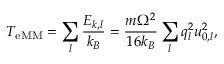Convert formula to latex. <formula><loc_0><loc_0><loc_500><loc_500>T _ { e M M } = \sum _ { l } \frac { E _ { k , l } } { k _ { B } } = \frac { m \Omega ^ { 2 } } { 1 6 k _ { B } } \sum _ { l } q _ { l } ^ { 2 } u _ { 0 , l } ^ { 2 } ,</formula> 